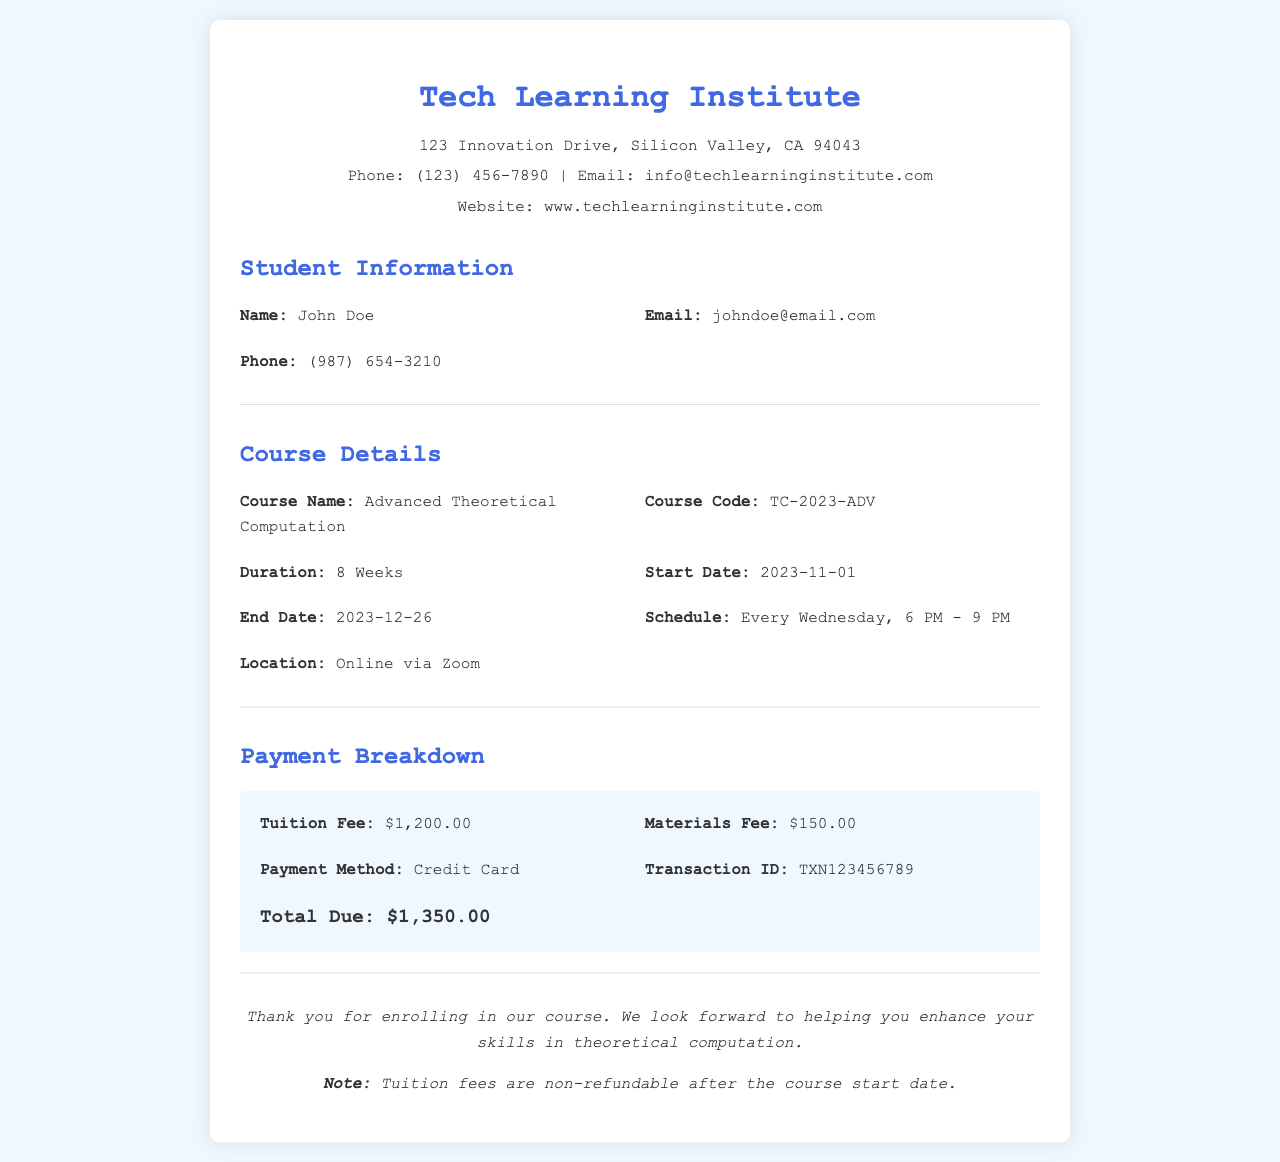What is the course name? The course name is indicated in the course details section of the document.
Answer: Advanced Theoretical Computation What is the duration of the course? The duration is found in the course details section, specifying the length of the course.
Answer: 8 Weeks What is the total due amount? The total due amount is summarized in the payment breakdown section of the receipt.
Answer: $1,350.00 On which day of the week does the course take place? The schedule portion of the course details specifies the day of the week for the course.
Answer: Every Wednesday What is the start date of the course? The start date is clearly mentioned in the course details section.
Answer: 2023-11-01 What is the payment method used? The payment breakdown section indicates the method used for payment.
Answer: Credit Card What is the transaction ID for the payment? The transaction ID is provided in the payment breakdown section for tracking purposes.
Answer: TXN123456789 What is the location of the course? The location is specified under the course details section and indicates where the course will be held.
Answer: Online via Zoom Is the tuition fee refundable after the course starts? The footer contains a note regarding the refund policy for the tuition fee.
Answer: No 